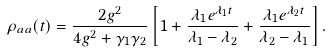Convert formula to latex. <formula><loc_0><loc_0><loc_500><loc_500>\rho _ { a a } ( t ) = \frac { 2 g ^ { 2 } } { 4 g ^ { 2 } + \gamma _ { 1 } \gamma _ { 2 } } \left [ 1 + \frac { \lambda _ { 1 } e ^ { \lambda _ { 1 } t } } { \lambda _ { 1 } - \lambda _ { 2 } } + \frac { \lambda _ { 1 } e ^ { \lambda _ { 2 } t } } { \lambda _ { 2 } - \lambda _ { 1 } } \right ] .</formula> 